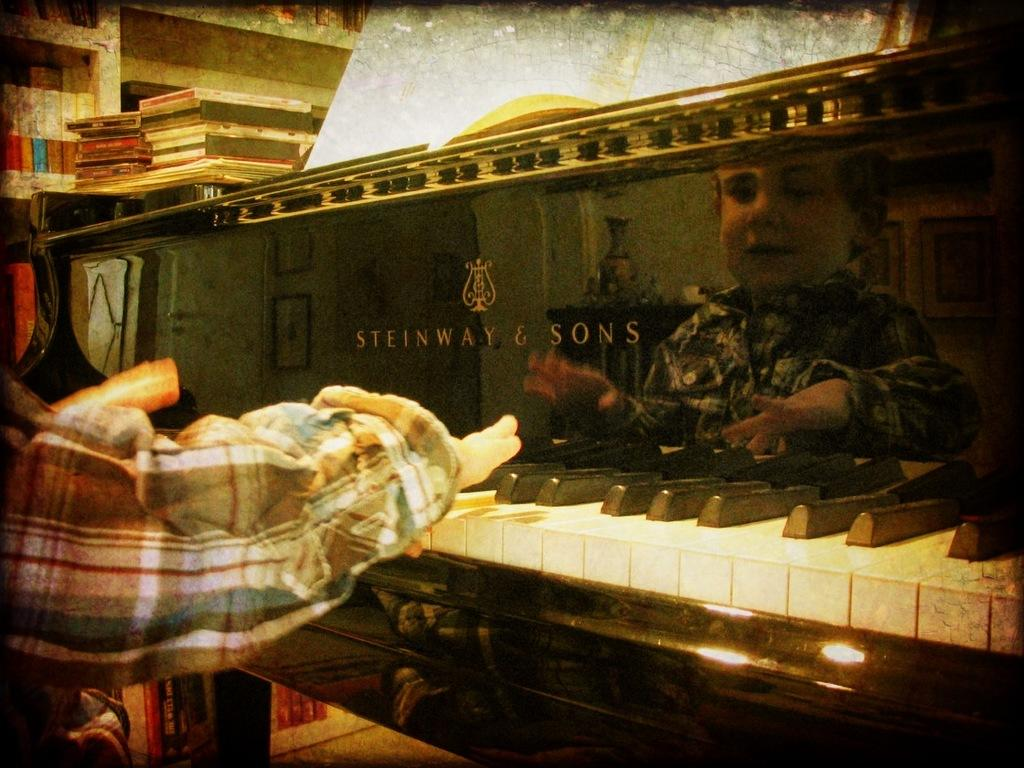What is the main subject of the image? The main subject of the image is a kid. What is the kid doing in the image? The kid is playing with a piano. Where is the piano located in relation to the kid? The piano is in front of the kid. What type of vessel is being used for business purposes in the image? There is no vessel or business activity present in the image; it features a kid playing with a piano. 